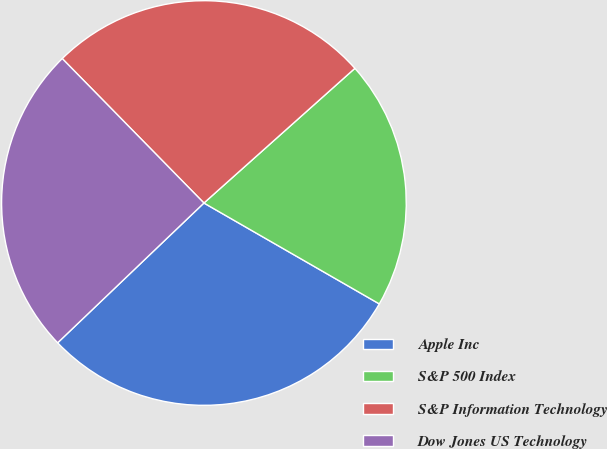<chart> <loc_0><loc_0><loc_500><loc_500><pie_chart><fcel>Apple Inc<fcel>S&P 500 Index<fcel>S&P Information Technology<fcel>Dow Jones US Technology<nl><fcel>29.55%<fcel>19.9%<fcel>25.75%<fcel>24.79%<nl></chart> 